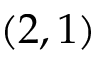<formula> <loc_0><loc_0><loc_500><loc_500>( 2 , 1 )</formula> 